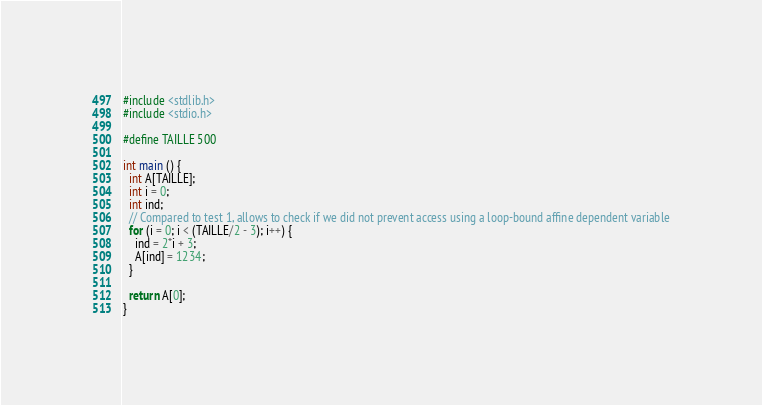Convert code to text. <code><loc_0><loc_0><loc_500><loc_500><_C_>#include <stdlib.h>
#include <stdio.h>

#define TAILLE 500

int main () {
  int A[TAILLE];
  int i = 0;
  int ind;
  // Compared to test 1, allows to check if we did not prevent access using a loop-bound affine dependent variable
  for (i = 0; i < (TAILLE/2 - 3); i++) {
    ind = 2*i + 3;
    A[ind] = 1234;
  }
    
  return A[0];
}
</code> 